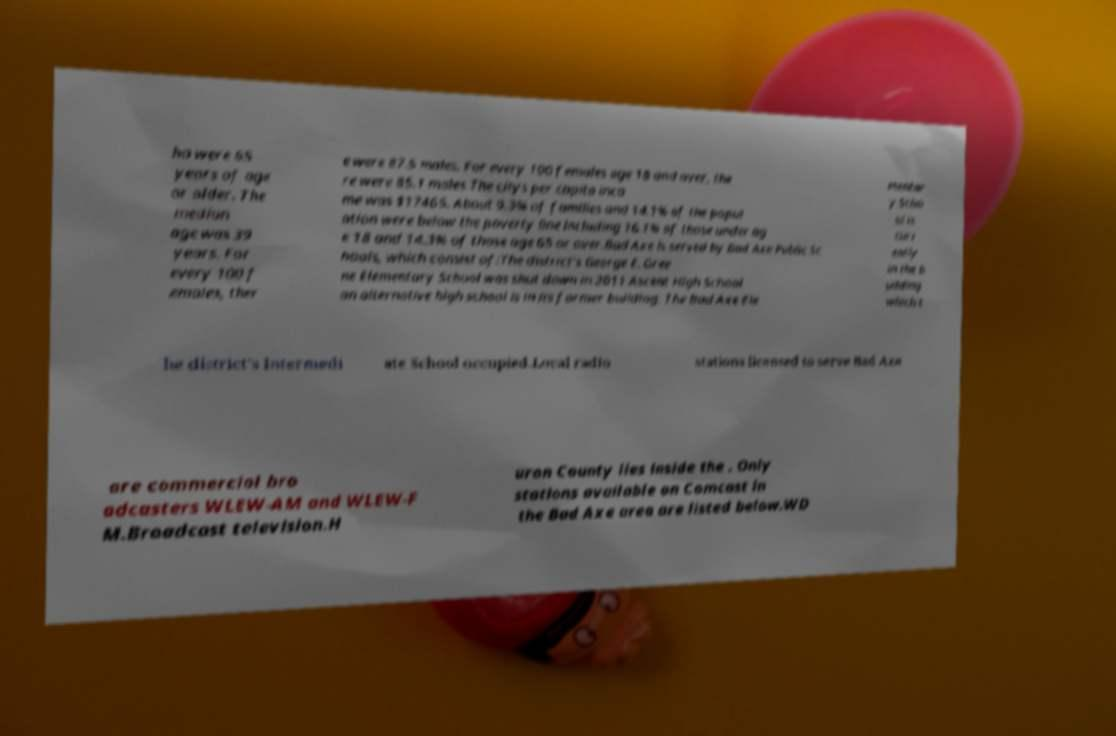Can you accurately transcribe the text from the provided image for me? ho were 65 years of age or older. The median age was 39 years. For every 100 f emales, ther e were 87.5 males. For every 100 females age 18 and over, the re were 85.1 males.The citys per capita inco me was $17465. About 9.3% of families and 14.1% of the popul ation were below the poverty line including 16.1% of those under ag e 18 and 14.3% of those age 65 or over.Bad Axe is served by Bad Axe Public Sc hools, which consist of:The district's George E. Gree ne Elementary School was shut down in 2011 Ascent High School an alternative high school is in its former building. The Bad Axe Ele mentar y Scho ol is curr ently in the b uilding which t he district's Intermedi ate School occupied.Local radio stations licensed to serve Bad Axe are commercial bro adcasters WLEW-AM and WLEW-F M.Broadcast television.H uron County lies inside the . Only stations available on Comcast in the Bad Axe area are listed below.WD 